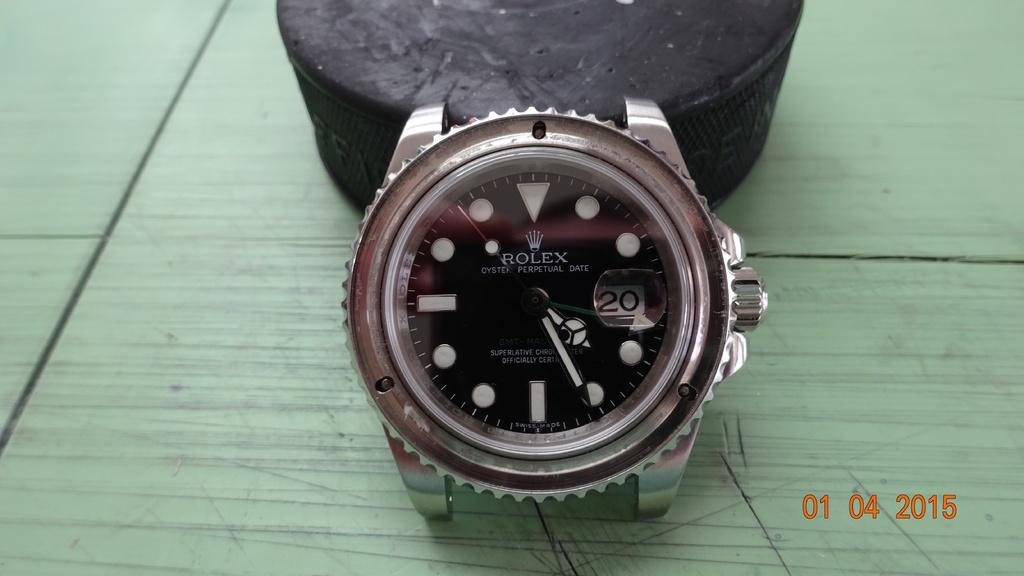<image>
Render a clear and concise summary of the photo. A Rolex brand watch is shown with a 2016 time stamp in the corner. 